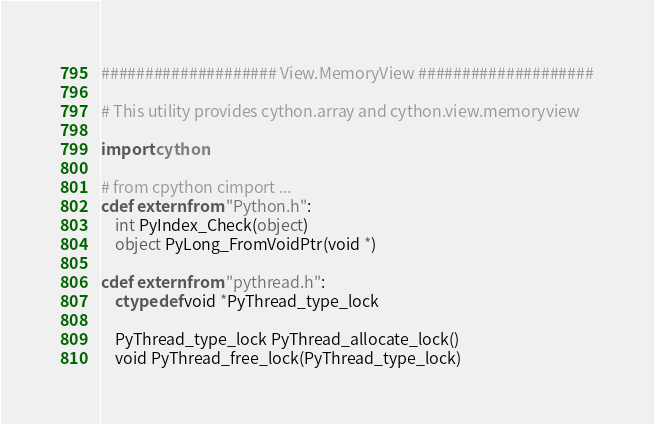Convert code to text. <code><loc_0><loc_0><loc_500><loc_500><_Cython_>#################### View.MemoryView ####################

# This utility provides cython.array and cython.view.memoryview

import cython

# from cpython cimport ...
cdef extern from "Python.h":
    int PyIndex_Check(object)
    object PyLong_FromVoidPtr(void *)

cdef extern from "pythread.h":
    ctypedef void *PyThread_type_lock

    PyThread_type_lock PyThread_allocate_lock()
    void PyThread_free_lock(PyThread_type_lock)</code> 